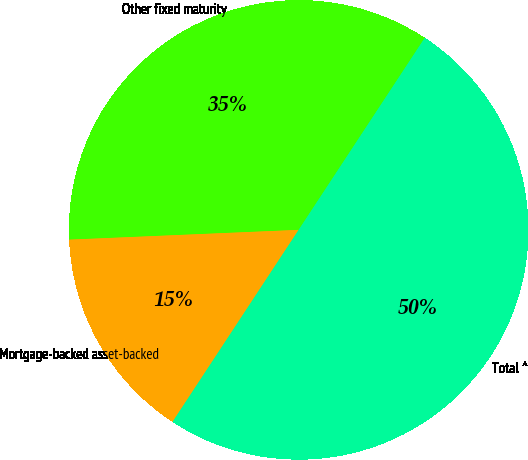Convert chart to OTSL. <chart><loc_0><loc_0><loc_500><loc_500><pie_chart><fcel>Other fixed maturity<fcel>Mortgage-backed asset-backed<fcel>Total ^<nl><fcel>34.93%<fcel>15.07%<fcel>50.0%<nl></chart> 